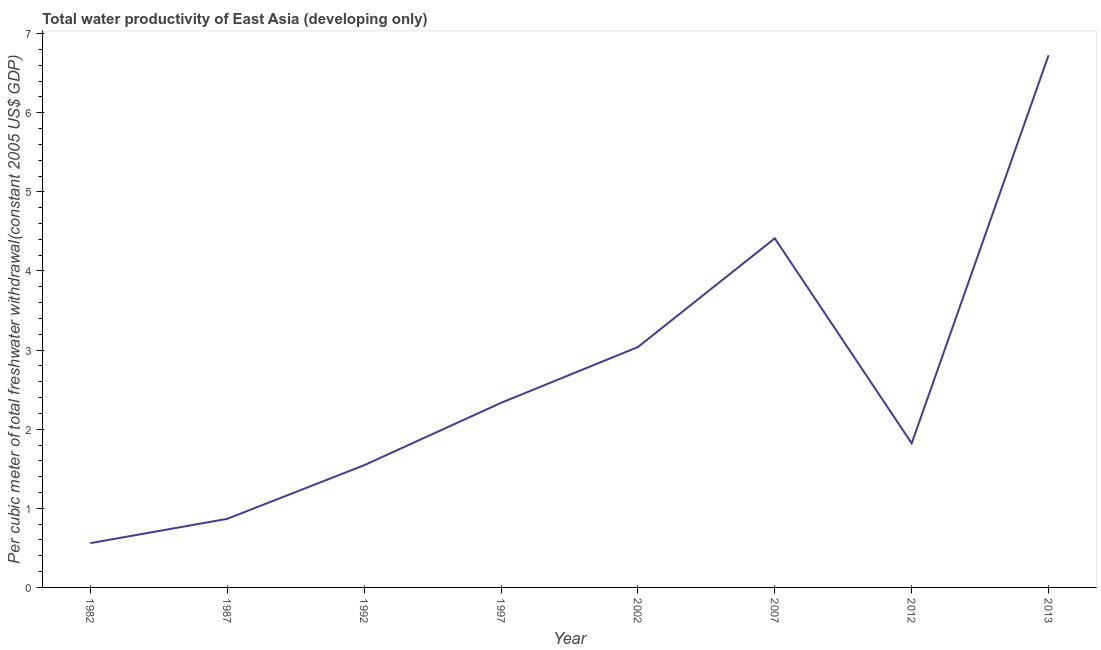What is the total water productivity in 1987?
Your response must be concise. 0.87. Across all years, what is the maximum total water productivity?
Provide a succinct answer. 6.73. Across all years, what is the minimum total water productivity?
Provide a short and direct response. 0.56. In which year was the total water productivity maximum?
Offer a terse response. 2013. What is the sum of the total water productivity?
Ensure brevity in your answer.  21.3. What is the difference between the total water productivity in 1982 and 1992?
Provide a short and direct response. -0.98. What is the average total water productivity per year?
Your answer should be compact. 2.66. What is the median total water productivity?
Keep it short and to the point. 2.08. In how many years, is the total water productivity greater than 4.4 US$?
Provide a short and direct response. 2. What is the ratio of the total water productivity in 1997 to that in 2007?
Keep it short and to the point. 0.53. Is the total water productivity in 1992 less than that in 2013?
Offer a very short reply. Yes. Is the difference between the total water productivity in 1987 and 2002 greater than the difference between any two years?
Make the answer very short. No. What is the difference between the highest and the second highest total water productivity?
Keep it short and to the point. 2.31. Is the sum of the total water productivity in 1987 and 2007 greater than the maximum total water productivity across all years?
Give a very brief answer. No. What is the difference between the highest and the lowest total water productivity?
Make the answer very short. 6.17. In how many years, is the total water productivity greater than the average total water productivity taken over all years?
Your answer should be compact. 3. Does the total water productivity monotonically increase over the years?
Provide a short and direct response. No. Does the graph contain any zero values?
Offer a terse response. No. What is the title of the graph?
Ensure brevity in your answer.  Total water productivity of East Asia (developing only). What is the label or title of the X-axis?
Give a very brief answer. Year. What is the label or title of the Y-axis?
Your answer should be compact. Per cubic meter of total freshwater withdrawal(constant 2005 US$ GDP). What is the Per cubic meter of total freshwater withdrawal(constant 2005 US$ GDP) of 1982?
Provide a short and direct response. 0.56. What is the Per cubic meter of total freshwater withdrawal(constant 2005 US$ GDP) in 1987?
Provide a succinct answer. 0.87. What is the Per cubic meter of total freshwater withdrawal(constant 2005 US$ GDP) of 1992?
Provide a succinct answer. 1.54. What is the Per cubic meter of total freshwater withdrawal(constant 2005 US$ GDP) in 1997?
Give a very brief answer. 2.33. What is the Per cubic meter of total freshwater withdrawal(constant 2005 US$ GDP) in 2002?
Provide a short and direct response. 3.04. What is the Per cubic meter of total freshwater withdrawal(constant 2005 US$ GDP) in 2007?
Your answer should be very brief. 4.41. What is the Per cubic meter of total freshwater withdrawal(constant 2005 US$ GDP) of 2012?
Your answer should be very brief. 1.82. What is the Per cubic meter of total freshwater withdrawal(constant 2005 US$ GDP) in 2013?
Your response must be concise. 6.73. What is the difference between the Per cubic meter of total freshwater withdrawal(constant 2005 US$ GDP) in 1982 and 1987?
Your answer should be compact. -0.31. What is the difference between the Per cubic meter of total freshwater withdrawal(constant 2005 US$ GDP) in 1982 and 1992?
Make the answer very short. -0.98. What is the difference between the Per cubic meter of total freshwater withdrawal(constant 2005 US$ GDP) in 1982 and 1997?
Make the answer very short. -1.77. What is the difference between the Per cubic meter of total freshwater withdrawal(constant 2005 US$ GDP) in 1982 and 2002?
Offer a terse response. -2.48. What is the difference between the Per cubic meter of total freshwater withdrawal(constant 2005 US$ GDP) in 1982 and 2007?
Your response must be concise. -3.85. What is the difference between the Per cubic meter of total freshwater withdrawal(constant 2005 US$ GDP) in 1982 and 2012?
Provide a succinct answer. -1.26. What is the difference between the Per cubic meter of total freshwater withdrawal(constant 2005 US$ GDP) in 1982 and 2013?
Your answer should be compact. -6.17. What is the difference between the Per cubic meter of total freshwater withdrawal(constant 2005 US$ GDP) in 1987 and 1992?
Your response must be concise. -0.68. What is the difference between the Per cubic meter of total freshwater withdrawal(constant 2005 US$ GDP) in 1987 and 1997?
Offer a terse response. -1.47. What is the difference between the Per cubic meter of total freshwater withdrawal(constant 2005 US$ GDP) in 1987 and 2002?
Give a very brief answer. -2.17. What is the difference between the Per cubic meter of total freshwater withdrawal(constant 2005 US$ GDP) in 1987 and 2007?
Ensure brevity in your answer.  -3.55. What is the difference between the Per cubic meter of total freshwater withdrawal(constant 2005 US$ GDP) in 1987 and 2012?
Offer a very short reply. -0.95. What is the difference between the Per cubic meter of total freshwater withdrawal(constant 2005 US$ GDP) in 1987 and 2013?
Ensure brevity in your answer.  -5.86. What is the difference between the Per cubic meter of total freshwater withdrawal(constant 2005 US$ GDP) in 1992 and 1997?
Provide a short and direct response. -0.79. What is the difference between the Per cubic meter of total freshwater withdrawal(constant 2005 US$ GDP) in 1992 and 2002?
Ensure brevity in your answer.  -1.49. What is the difference between the Per cubic meter of total freshwater withdrawal(constant 2005 US$ GDP) in 1992 and 2007?
Give a very brief answer. -2.87. What is the difference between the Per cubic meter of total freshwater withdrawal(constant 2005 US$ GDP) in 1992 and 2012?
Make the answer very short. -0.28. What is the difference between the Per cubic meter of total freshwater withdrawal(constant 2005 US$ GDP) in 1992 and 2013?
Provide a succinct answer. -5.18. What is the difference between the Per cubic meter of total freshwater withdrawal(constant 2005 US$ GDP) in 1997 and 2002?
Ensure brevity in your answer.  -0.71. What is the difference between the Per cubic meter of total freshwater withdrawal(constant 2005 US$ GDP) in 1997 and 2007?
Provide a short and direct response. -2.08. What is the difference between the Per cubic meter of total freshwater withdrawal(constant 2005 US$ GDP) in 1997 and 2012?
Keep it short and to the point. 0.51. What is the difference between the Per cubic meter of total freshwater withdrawal(constant 2005 US$ GDP) in 1997 and 2013?
Provide a succinct answer. -4.39. What is the difference between the Per cubic meter of total freshwater withdrawal(constant 2005 US$ GDP) in 2002 and 2007?
Your answer should be compact. -1.37. What is the difference between the Per cubic meter of total freshwater withdrawal(constant 2005 US$ GDP) in 2002 and 2012?
Offer a very short reply. 1.22. What is the difference between the Per cubic meter of total freshwater withdrawal(constant 2005 US$ GDP) in 2002 and 2013?
Your answer should be very brief. -3.69. What is the difference between the Per cubic meter of total freshwater withdrawal(constant 2005 US$ GDP) in 2007 and 2012?
Provide a short and direct response. 2.59. What is the difference between the Per cubic meter of total freshwater withdrawal(constant 2005 US$ GDP) in 2007 and 2013?
Keep it short and to the point. -2.31. What is the difference between the Per cubic meter of total freshwater withdrawal(constant 2005 US$ GDP) in 2012 and 2013?
Your answer should be very brief. -4.91. What is the ratio of the Per cubic meter of total freshwater withdrawal(constant 2005 US$ GDP) in 1982 to that in 1987?
Offer a terse response. 0.65. What is the ratio of the Per cubic meter of total freshwater withdrawal(constant 2005 US$ GDP) in 1982 to that in 1992?
Offer a very short reply. 0.36. What is the ratio of the Per cubic meter of total freshwater withdrawal(constant 2005 US$ GDP) in 1982 to that in 1997?
Make the answer very short. 0.24. What is the ratio of the Per cubic meter of total freshwater withdrawal(constant 2005 US$ GDP) in 1982 to that in 2002?
Provide a succinct answer. 0.18. What is the ratio of the Per cubic meter of total freshwater withdrawal(constant 2005 US$ GDP) in 1982 to that in 2007?
Ensure brevity in your answer.  0.13. What is the ratio of the Per cubic meter of total freshwater withdrawal(constant 2005 US$ GDP) in 1982 to that in 2012?
Your response must be concise. 0.31. What is the ratio of the Per cubic meter of total freshwater withdrawal(constant 2005 US$ GDP) in 1982 to that in 2013?
Provide a succinct answer. 0.08. What is the ratio of the Per cubic meter of total freshwater withdrawal(constant 2005 US$ GDP) in 1987 to that in 1992?
Make the answer very short. 0.56. What is the ratio of the Per cubic meter of total freshwater withdrawal(constant 2005 US$ GDP) in 1987 to that in 1997?
Provide a short and direct response. 0.37. What is the ratio of the Per cubic meter of total freshwater withdrawal(constant 2005 US$ GDP) in 1987 to that in 2002?
Offer a terse response. 0.28. What is the ratio of the Per cubic meter of total freshwater withdrawal(constant 2005 US$ GDP) in 1987 to that in 2007?
Provide a short and direct response. 0.2. What is the ratio of the Per cubic meter of total freshwater withdrawal(constant 2005 US$ GDP) in 1987 to that in 2012?
Offer a very short reply. 0.48. What is the ratio of the Per cubic meter of total freshwater withdrawal(constant 2005 US$ GDP) in 1987 to that in 2013?
Provide a short and direct response. 0.13. What is the ratio of the Per cubic meter of total freshwater withdrawal(constant 2005 US$ GDP) in 1992 to that in 1997?
Keep it short and to the point. 0.66. What is the ratio of the Per cubic meter of total freshwater withdrawal(constant 2005 US$ GDP) in 1992 to that in 2002?
Your answer should be compact. 0.51. What is the ratio of the Per cubic meter of total freshwater withdrawal(constant 2005 US$ GDP) in 1992 to that in 2007?
Keep it short and to the point. 0.35. What is the ratio of the Per cubic meter of total freshwater withdrawal(constant 2005 US$ GDP) in 1992 to that in 2012?
Provide a succinct answer. 0.85. What is the ratio of the Per cubic meter of total freshwater withdrawal(constant 2005 US$ GDP) in 1992 to that in 2013?
Give a very brief answer. 0.23. What is the ratio of the Per cubic meter of total freshwater withdrawal(constant 2005 US$ GDP) in 1997 to that in 2002?
Ensure brevity in your answer.  0.77. What is the ratio of the Per cubic meter of total freshwater withdrawal(constant 2005 US$ GDP) in 1997 to that in 2007?
Your response must be concise. 0.53. What is the ratio of the Per cubic meter of total freshwater withdrawal(constant 2005 US$ GDP) in 1997 to that in 2012?
Keep it short and to the point. 1.28. What is the ratio of the Per cubic meter of total freshwater withdrawal(constant 2005 US$ GDP) in 1997 to that in 2013?
Keep it short and to the point. 0.35. What is the ratio of the Per cubic meter of total freshwater withdrawal(constant 2005 US$ GDP) in 2002 to that in 2007?
Your answer should be compact. 0.69. What is the ratio of the Per cubic meter of total freshwater withdrawal(constant 2005 US$ GDP) in 2002 to that in 2012?
Your answer should be very brief. 1.67. What is the ratio of the Per cubic meter of total freshwater withdrawal(constant 2005 US$ GDP) in 2002 to that in 2013?
Give a very brief answer. 0.45. What is the ratio of the Per cubic meter of total freshwater withdrawal(constant 2005 US$ GDP) in 2007 to that in 2012?
Your answer should be compact. 2.42. What is the ratio of the Per cubic meter of total freshwater withdrawal(constant 2005 US$ GDP) in 2007 to that in 2013?
Your response must be concise. 0.66. What is the ratio of the Per cubic meter of total freshwater withdrawal(constant 2005 US$ GDP) in 2012 to that in 2013?
Offer a terse response. 0.27. 